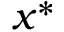Convert formula to latex. <formula><loc_0><loc_0><loc_500><loc_500>x ^ { * }</formula> 